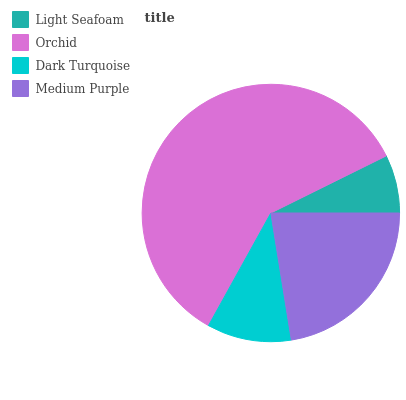Is Light Seafoam the minimum?
Answer yes or no. Yes. Is Orchid the maximum?
Answer yes or no. Yes. Is Dark Turquoise the minimum?
Answer yes or no. No. Is Dark Turquoise the maximum?
Answer yes or no. No. Is Orchid greater than Dark Turquoise?
Answer yes or no. Yes. Is Dark Turquoise less than Orchid?
Answer yes or no. Yes. Is Dark Turquoise greater than Orchid?
Answer yes or no. No. Is Orchid less than Dark Turquoise?
Answer yes or no. No. Is Medium Purple the high median?
Answer yes or no. Yes. Is Dark Turquoise the low median?
Answer yes or no. Yes. Is Light Seafoam the high median?
Answer yes or no. No. Is Orchid the low median?
Answer yes or no. No. 